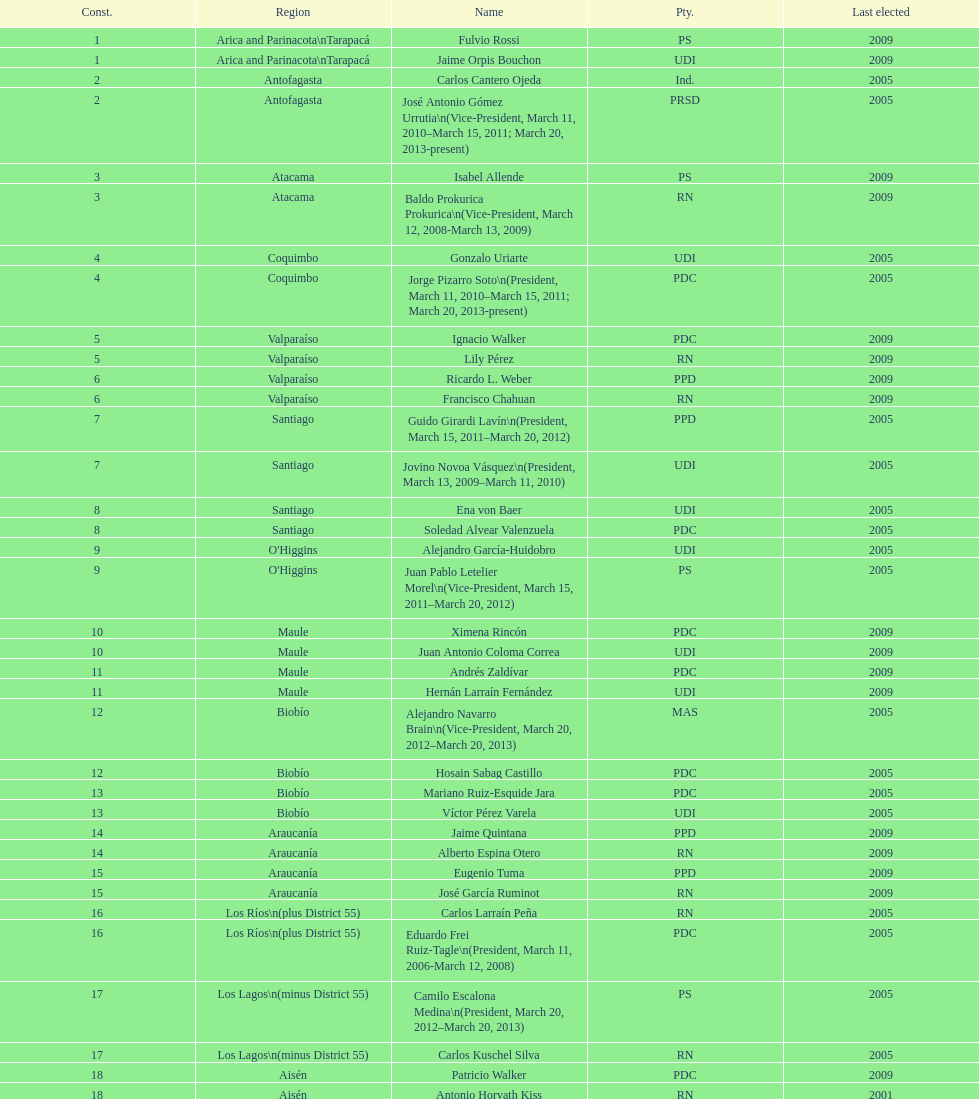What is the concluding region presented in the table? Magallanes. 